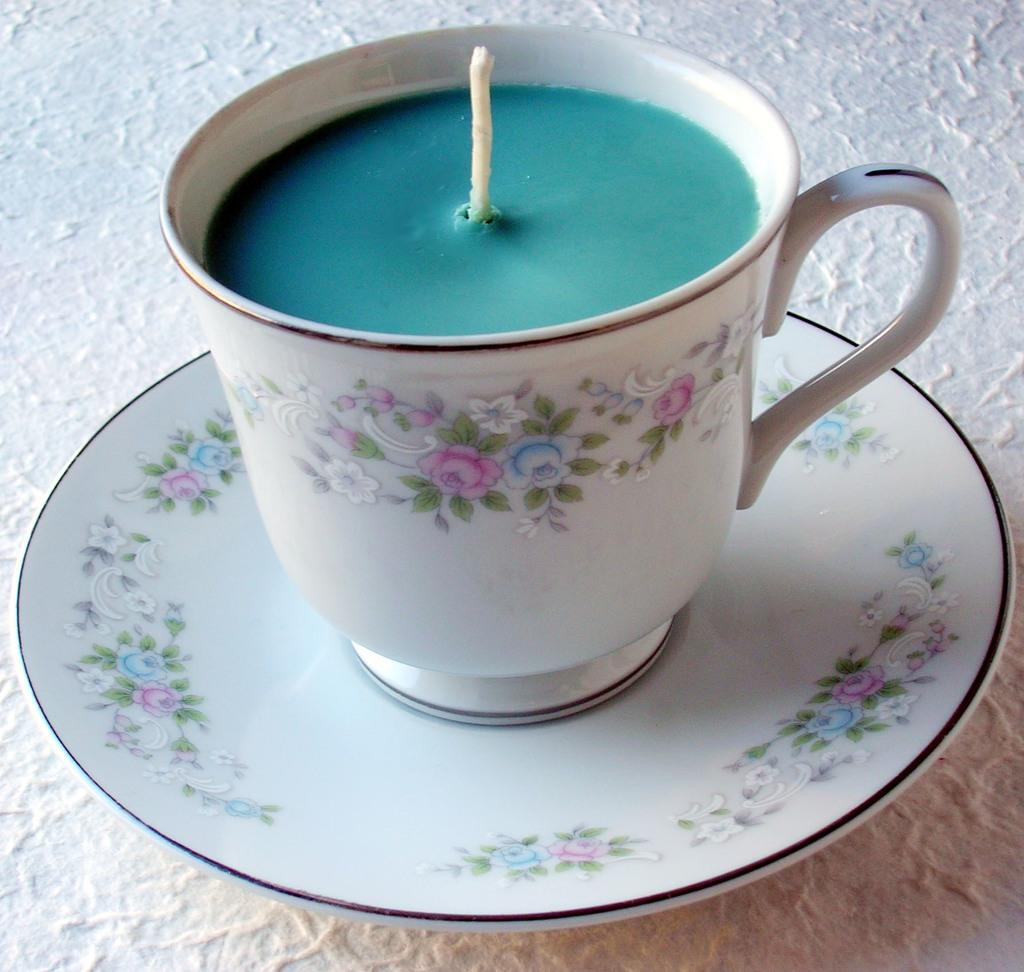What substance is present in the image? There is candle wax in the image. What color is the candle wax? The candle wax is blue in color. What is the candle wax contained in? The candle wax is in a white color cup. What other object is present in the image? There is a saucer in the image. What type of tank is visible in the image? There is no tank present in the image; it features candle wax in a cup and a saucer. 